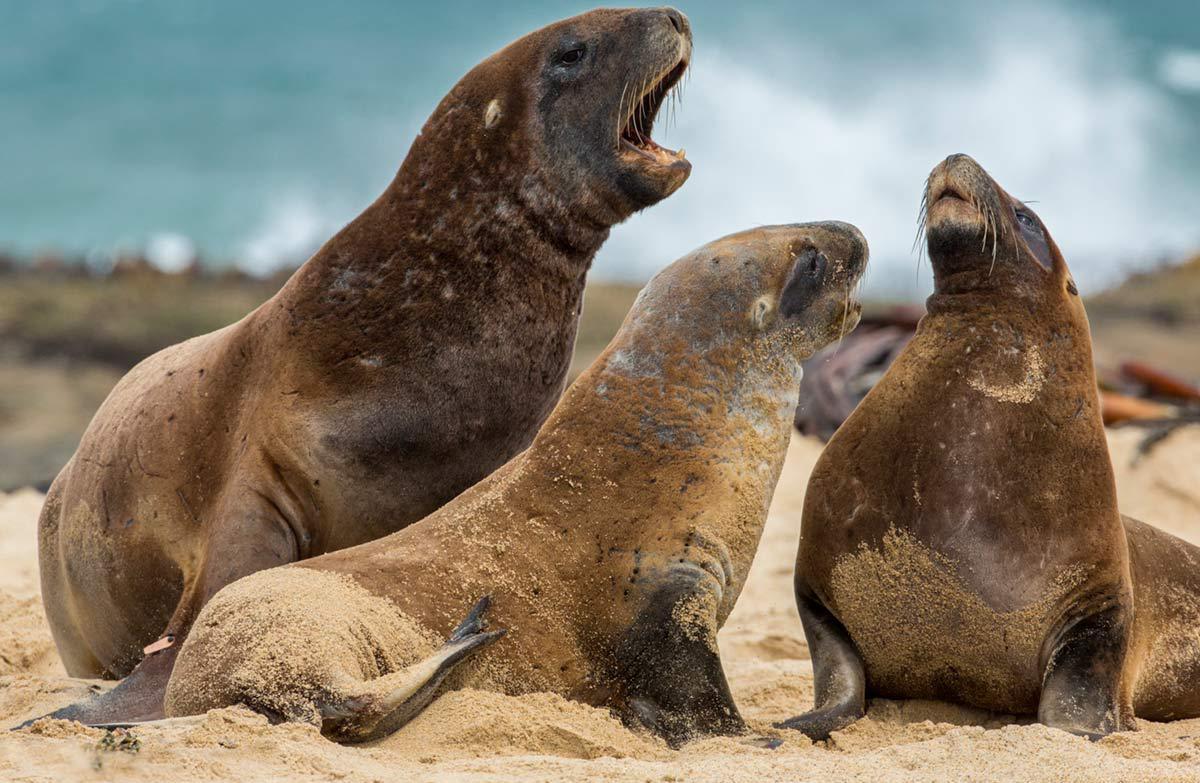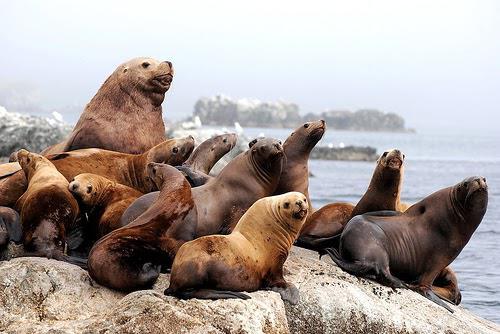The first image is the image on the left, the second image is the image on the right. Assess this claim about the two images: "One image contains exactly three seals.". Correct or not? Answer yes or no. Yes. 